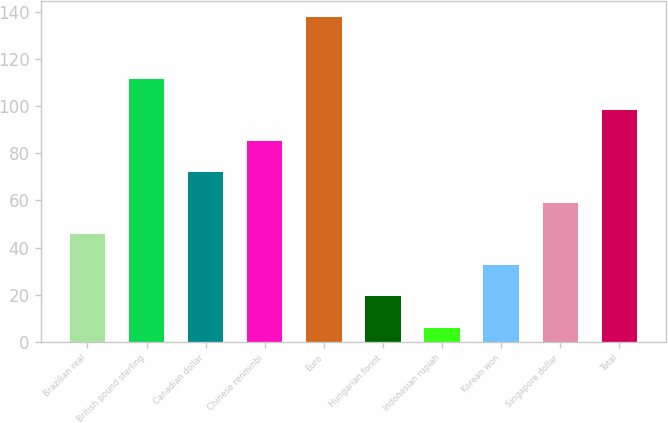Convert chart. <chart><loc_0><loc_0><loc_500><loc_500><bar_chart><fcel>Brazilian real<fcel>British pound sterling<fcel>Canadian dollar<fcel>Chinese renminbi<fcel>Euro<fcel>Hungarian forint<fcel>Indonesian rupiah<fcel>Korean won<fcel>Singapore dollar<fcel>Total<nl><fcel>45.6<fcel>111.6<fcel>72<fcel>85.2<fcel>138<fcel>19.2<fcel>6<fcel>32.4<fcel>58.8<fcel>98.4<nl></chart> 